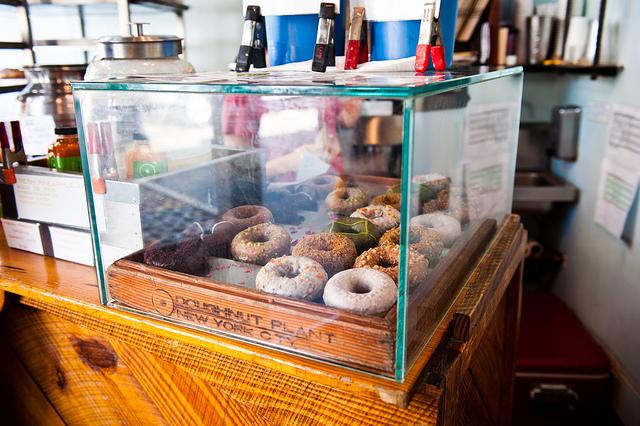Are these donuts?
Answer briefly. Yes. Does this place sell accessories?
Write a very short answer. No. Are the donuts arranged in a pattern?
Concise answer only. No. What kind of food is this?
Write a very short answer. Donuts. 